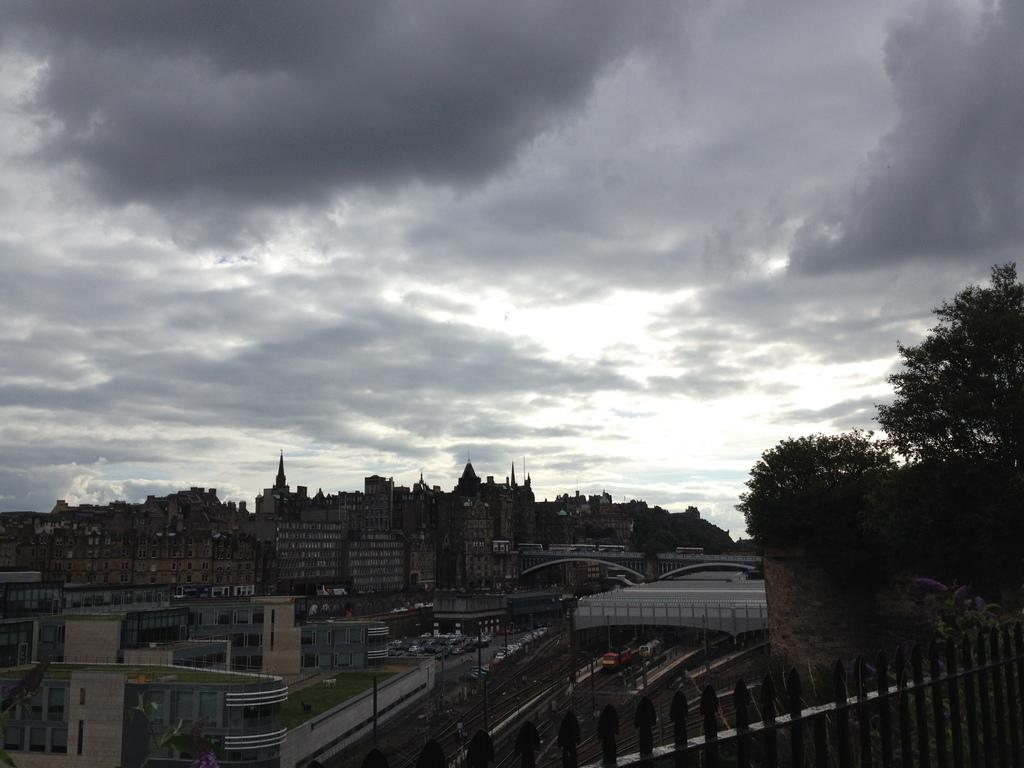What type of structures can be seen in the image? There are buildings in the image. What other natural elements are present in the image? There are trees in the image. What type of man-made structure is visible in the image? There is a bridge in the image. What type of transportation can be seen in the image? There are vehicles on a path in the image. How would you describe the weather in the image? The sky is cloudy in the image. Where is the basin located in the image? There is there any learning activity taking place in the image? 